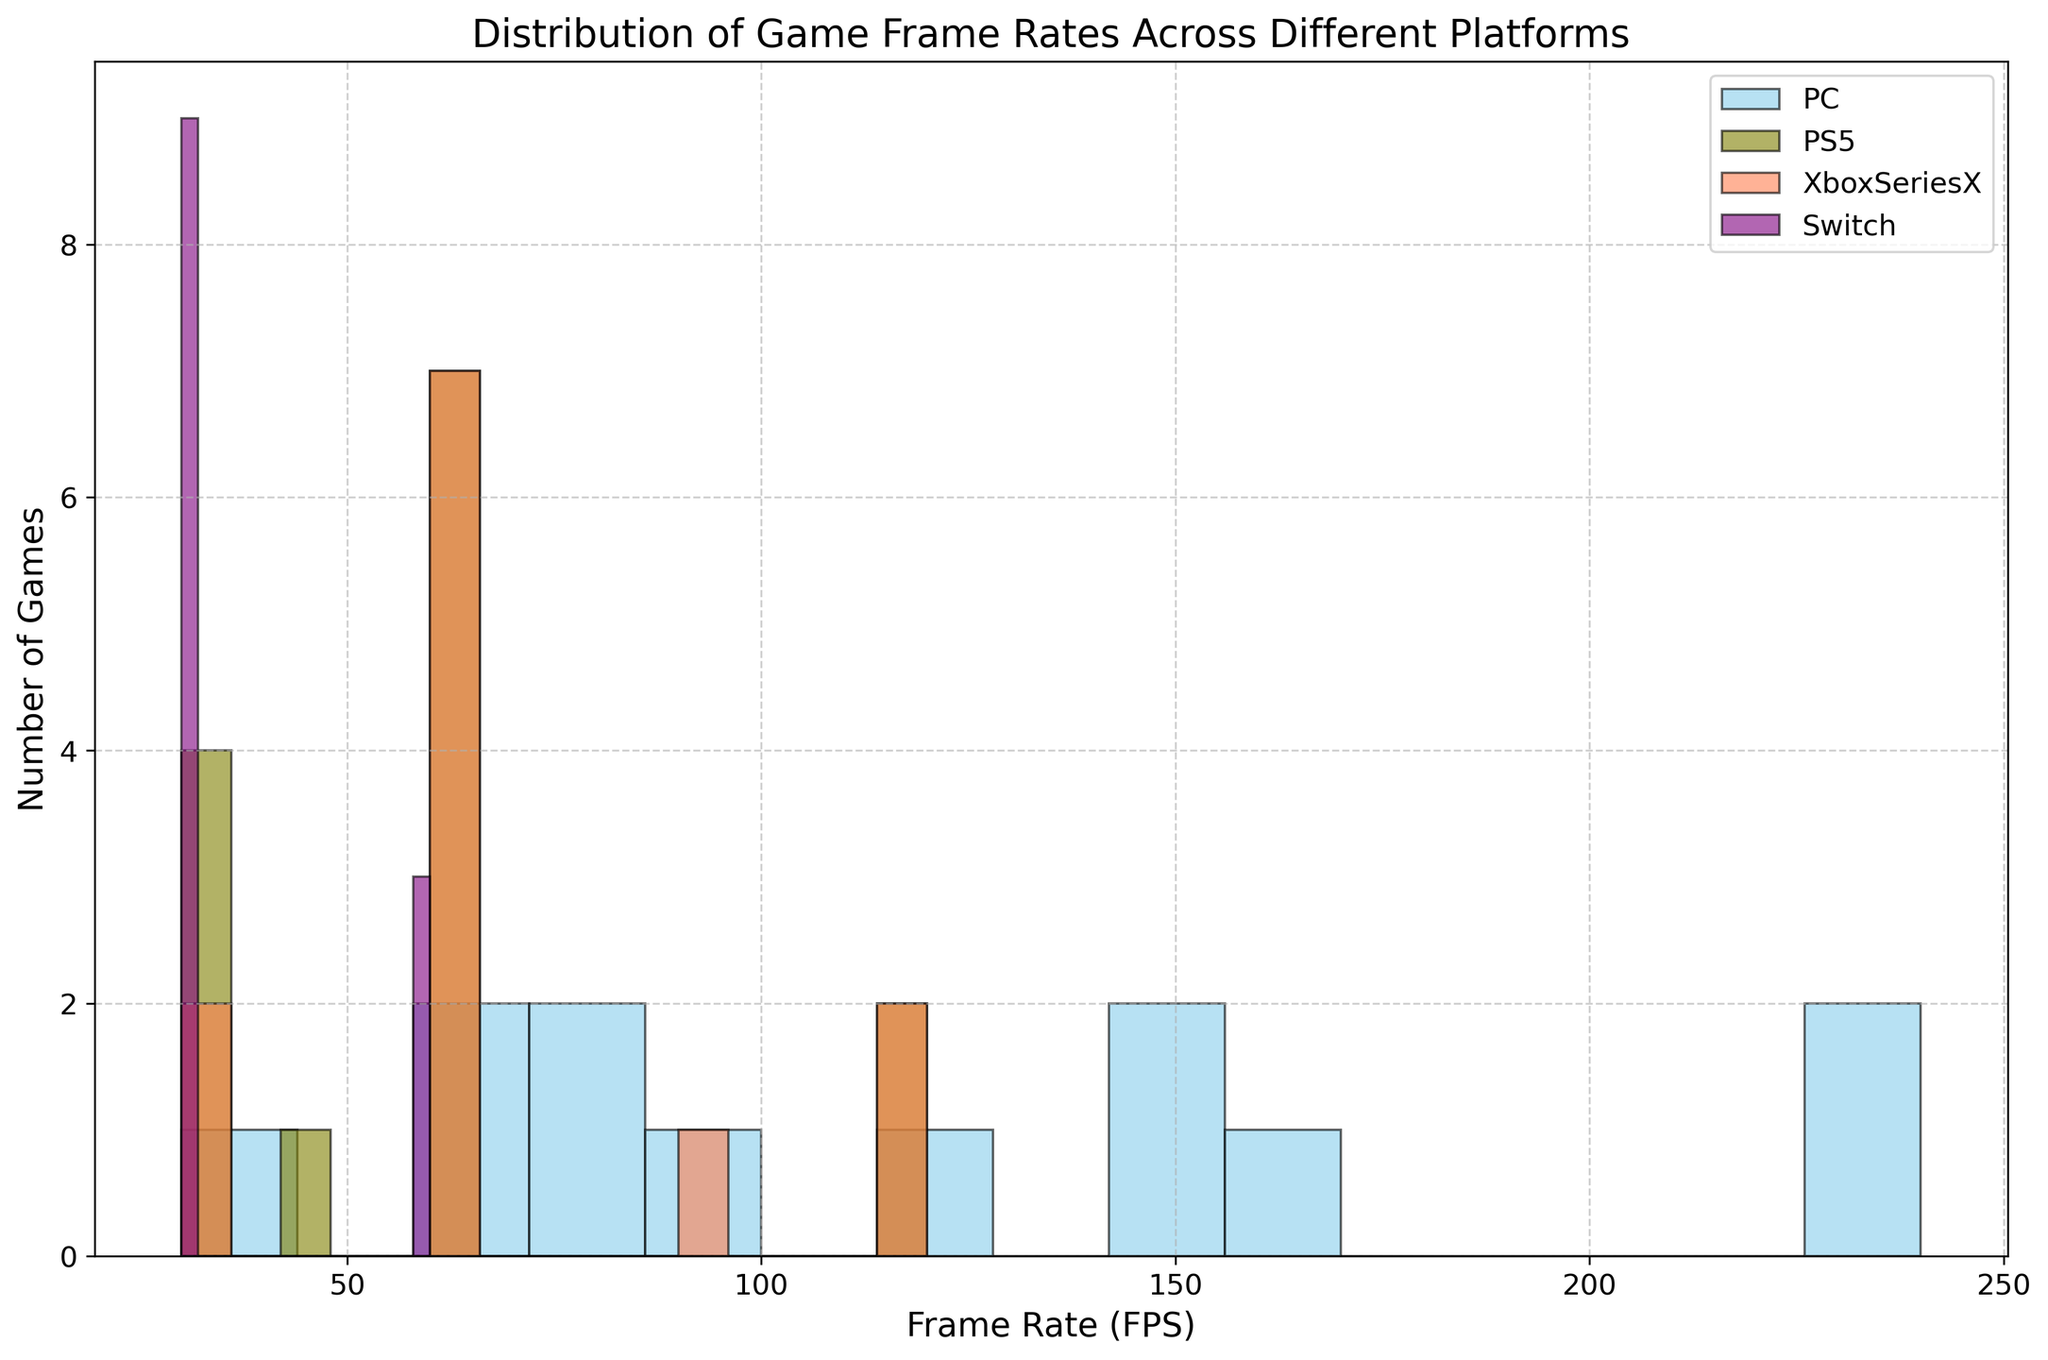What is the most common frame rate for games on the Nintendo Switch? The histogram for the Nintendo Switch is the one with purple bars. By observing the height of the bars, it appears that the 30 FPS bar is the tallest, indicating it has the highest frequency.
Answer: 30 FPS Which platform has the highest variety of frame rates mentioned? By examining the histograms, the PC platform (skyblue bars) shows the most spread-out distribution with several different heights, indicating different frame rates such as 30, 60, 75, 85, 90, 120, 144, 165, 240 FPS.
Answer: PC How does the distribution of frame rates for Xbox Series X compare to that of PS5? Both platforms have distributions of similar frame rates like 30, 60, and 120 FPS. However, Xbox Series X seems to also have a 90 FPS frame rate not present in the PS5’s distribution. The frequencies (heights of bars) for comparable frame rates are also similar.
Answer: Similar with slight differences What is the average frame rate for PS5 games if we exclude the 30 FPS rate? Exclude the 30 FPS data first (5 instances). Remaining frame rates for PS5 are 60 (6), 45 (1), 120 (2). (60*6 + 45*1 + 120*2) / (9) equals to (360 + 45 + 240)/9 = 645/9 = 71.67 FPS.
Answer: 71.67 FPS How many total games are there across all platforms? Count the bars’ heights for all platforms (combining individual counts visually). It appears to be PC: 12, PS5: 12, Xbox Series X: 10, Switch: 10. Adding these together, we get 12 + 12 + 10 + 10 = 44.
Answer: 44 If you want games that consistently run at 120 FPS, on which platform would you look? By observing the histograms, you can see that the PC (skyblue) and PS5 (olive) platforms have bars at 120 FPS, indicating they have games running at this frame rate.
Answer: PC, PS5 What is the difference in the frequency of games running at 60 FPS between the Xbox Series X and the Nintendo Switch? By looking at the histogram bars’ heights, count the frequency of 60 FPS for Xbox Series X (5) and Nintendo Switch (2). The difference is 5 - 2 = 3.
Answer: 3 Which platform has the least variation in frame rates? The Nintendo Switch (purple bars) shows the least variation as most of the games cluster around 30 FPS, with only a few at 60 FPS. The other platforms have more distributed values.
Answer: Nintendo Switch What is the median frame rate for PC games? First, list the frame rates for PC: [30, 60, 60, 75, 85, 90, 120, 144, 144, 165, 240, 240]. The median is the average of the two middle numbers in this ordered list: (90 + 120) / 2 = 105.
Answer: 105 